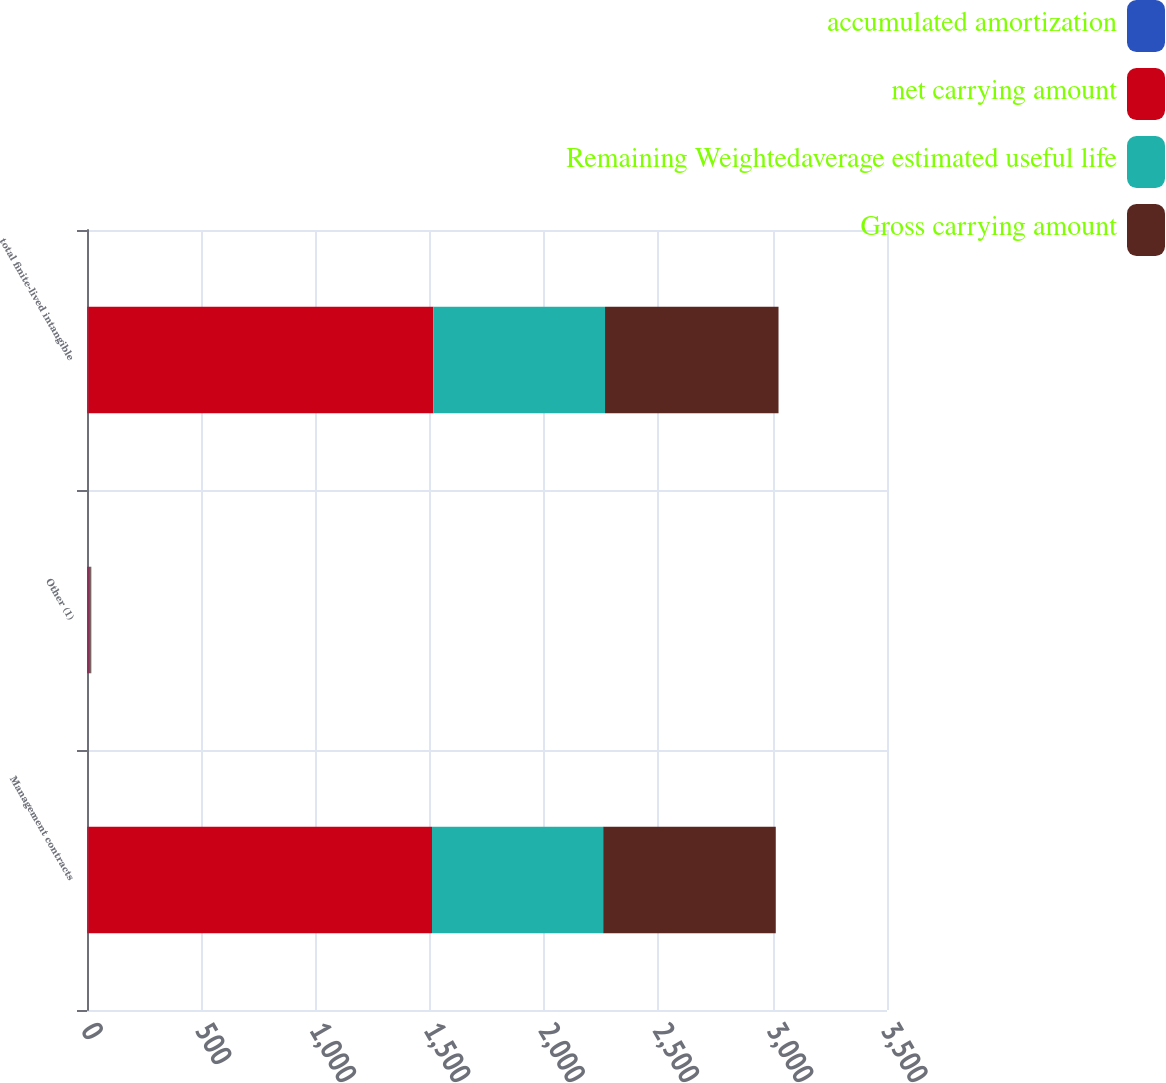Convert chart to OTSL. <chart><loc_0><loc_0><loc_500><loc_500><stacked_bar_chart><ecel><fcel>Management contracts<fcel>Other (1)<fcel>total finite-lived intangible<nl><fcel>accumulated amortization<fcel>5.4<fcel>6.6<fcel>5.4<nl><fcel>net carrying amount<fcel>1504<fcel>6<fcel>1510<nl><fcel>Remaining Weightedaverage estimated useful life<fcel>749<fcel>2<fcel>751<nl><fcel>Gross carrying amount<fcel>755<fcel>4<fcel>759<nl></chart> 